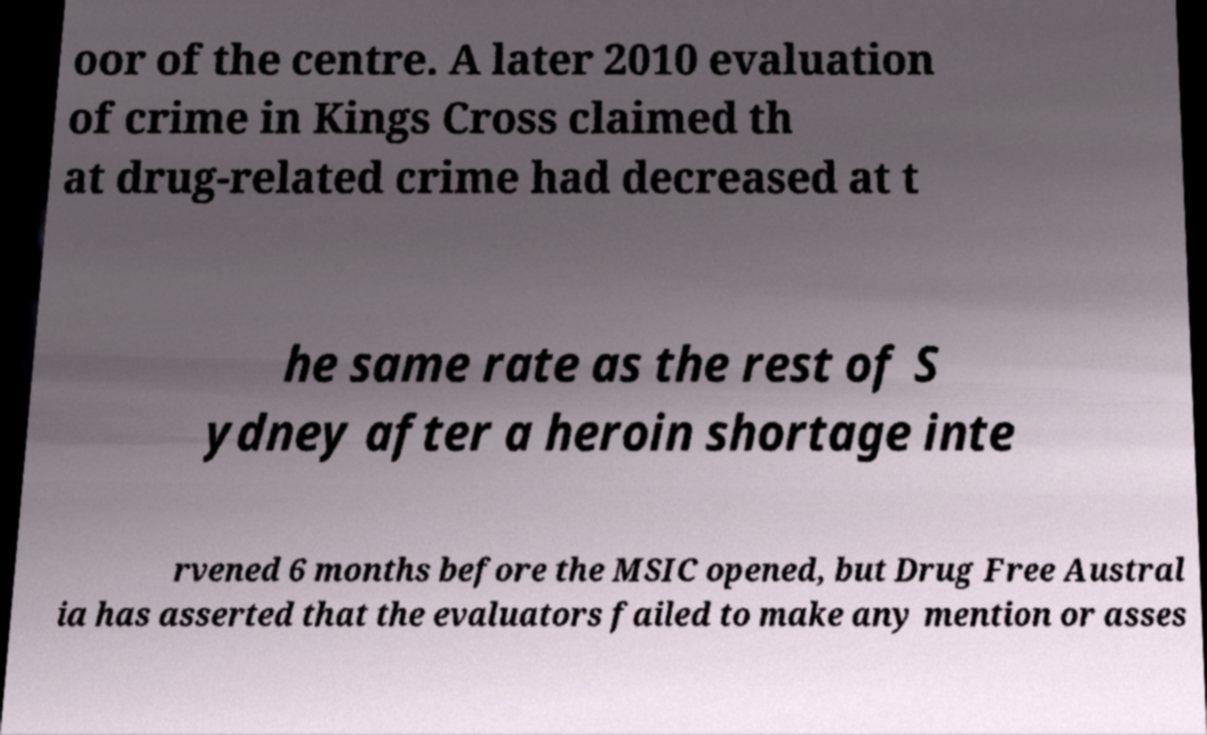For documentation purposes, I need the text within this image transcribed. Could you provide that? oor of the centre. A later 2010 evaluation of crime in Kings Cross claimed th at drug-related crime had decreased at t he same rate as the rest of S ydney after a heroin shortage inte rvened 6 months before the MSIC opened, but Drug Free Austral ia has asserted that the evaluators failed to make any mention or asses 